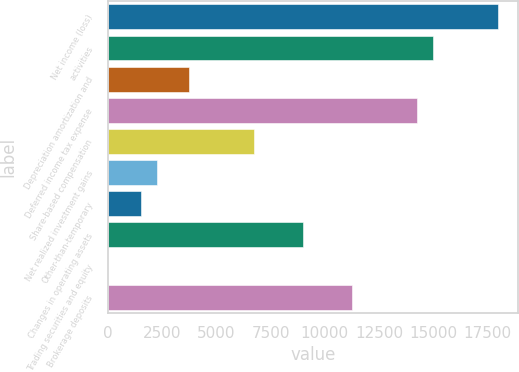<chart> <loc_0><loc_0><loc_500><loc_500><bar_chart><fcel>Net income (loss)<fcel>activities<fcel>Depreciation amortization and<fcel>Deferred income tax expense<fcel>Share-based compensation<fcel>Net realized investment gains<fcel>Other-than-temporary<fcel>Changes in operating assets<fcel>Trading securities and equity<fcel>Brokerage deposits<nl><fcel>18003.4<fcel>15003<fcel>3751.5<fcel>14252.9<fcel>6751.9<fcel>2251.3<fcel>1501.2<fcel>9002.2<fcel>1<fcel>11252.5<nl></chart> 